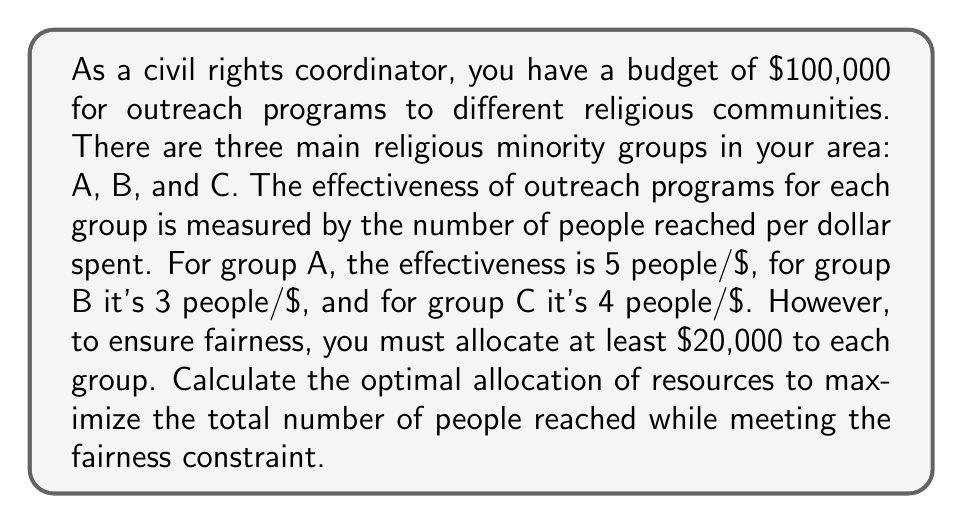Give your solution to this math problem. To solve this problem, we'll use linear programming. Let's define our variables:

$x_A$: Amount allocated to group A
$x_B$: Amount allocated to group B
$x_C$: Amount allocated to group C

Our objective function is to maximize the total number of people reached:

$$\text{Maximize: } 5x_A + 3x_B + 4x_C$$

Subject to the following constraints:

1. Total budget constraint: $x_A + x_B + x_C \leq 100,000$
2. Fairness constraints: $x_A \geq 20,000$, $x_B \geq 20,000$, $x_C \geq 20,000$
3. Non-negativity constraints: $x_A, x_B, x_C \geq 0$

To solve this, we'll use the following steps:

1. Allocate the minimum required amount to each group:
   $x_A = x_B = x_C = 20,000$
   Remaining budget: $100,000 - (3 * 20,000) = 40,000$

2. Allocate the remaining budget to the group with the highest effectiveness:
   Group A has the highest effectiveness (5 people/$), so we allocate the remaining $40,000 to group A.

3. Final allocation:
   Group A: $20,000 + 40,000 = 60,000$
   Group B: $20,000$
   Group C: $20,000$

4. Calculate the total number of people reached:
   Group A: $5 * 60,000 = 300,000$
   Group B: $3 * 20,000 = 60,000$
   Group C: $4 * 20,000 = 80,000$
   Total: $300,000 + 60,000 + 80,000 = 440,000$

Therefore, the optimal allocation is $60,000 to group A, $20,000 to group B, and $20,000 to group C, reaching a total of 440,000 people.
Answer: The optimal allocation is:
Group A: $60,000
Group B: $20,000
Group C: $20,000
Total people reached: 440,000 